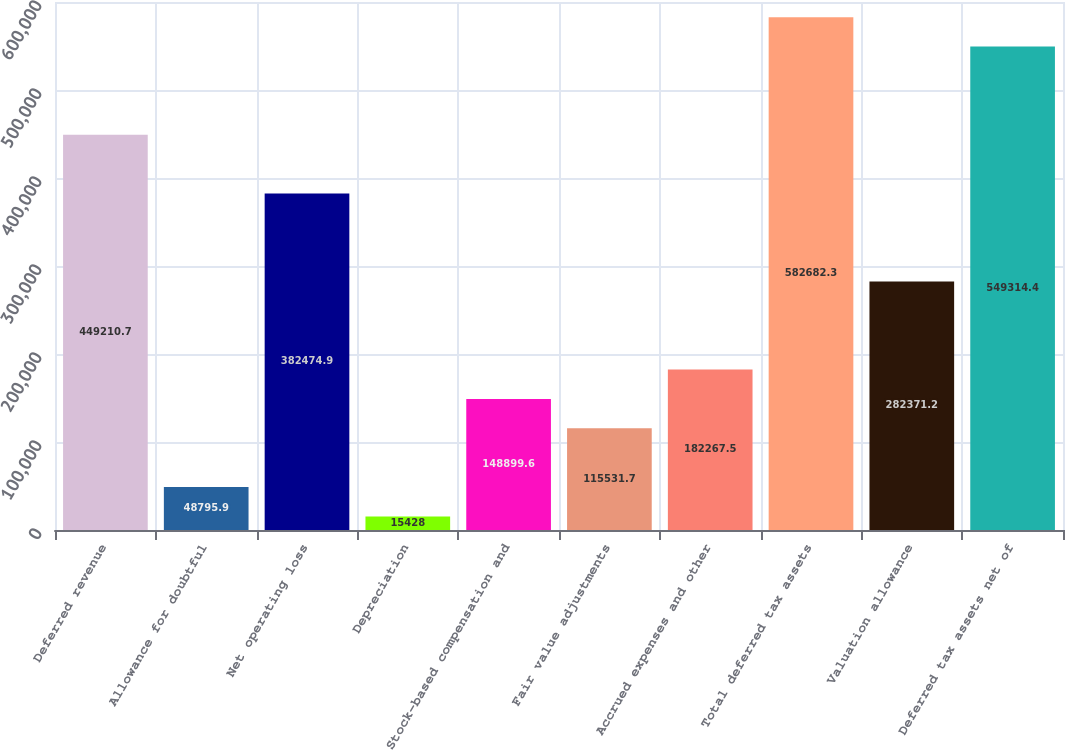Convert chart to OTSL. <chart><loc_0><loc_0><loc_500><loc_500><bar_chart><fcel>Deferred revenue<fcel>Allowance for doubtful<fcel>Net operating loss<fcel>Depreciation<fcel>Stock-based compensation and<fcel>Fair value adjustments<fcel>Accrued expenses and other<fcel>Total deferred tax assets<fcel>Valuation allowance<fcel>Deferred tax assets net of<nl><fcel>449211<fcel>48795.9<fcel>382475<fcel>15428<fcel>148900<fcel>115532<fcel>182268<fcel>582682<fcel>282371<fcel>549314<nl></chart> 